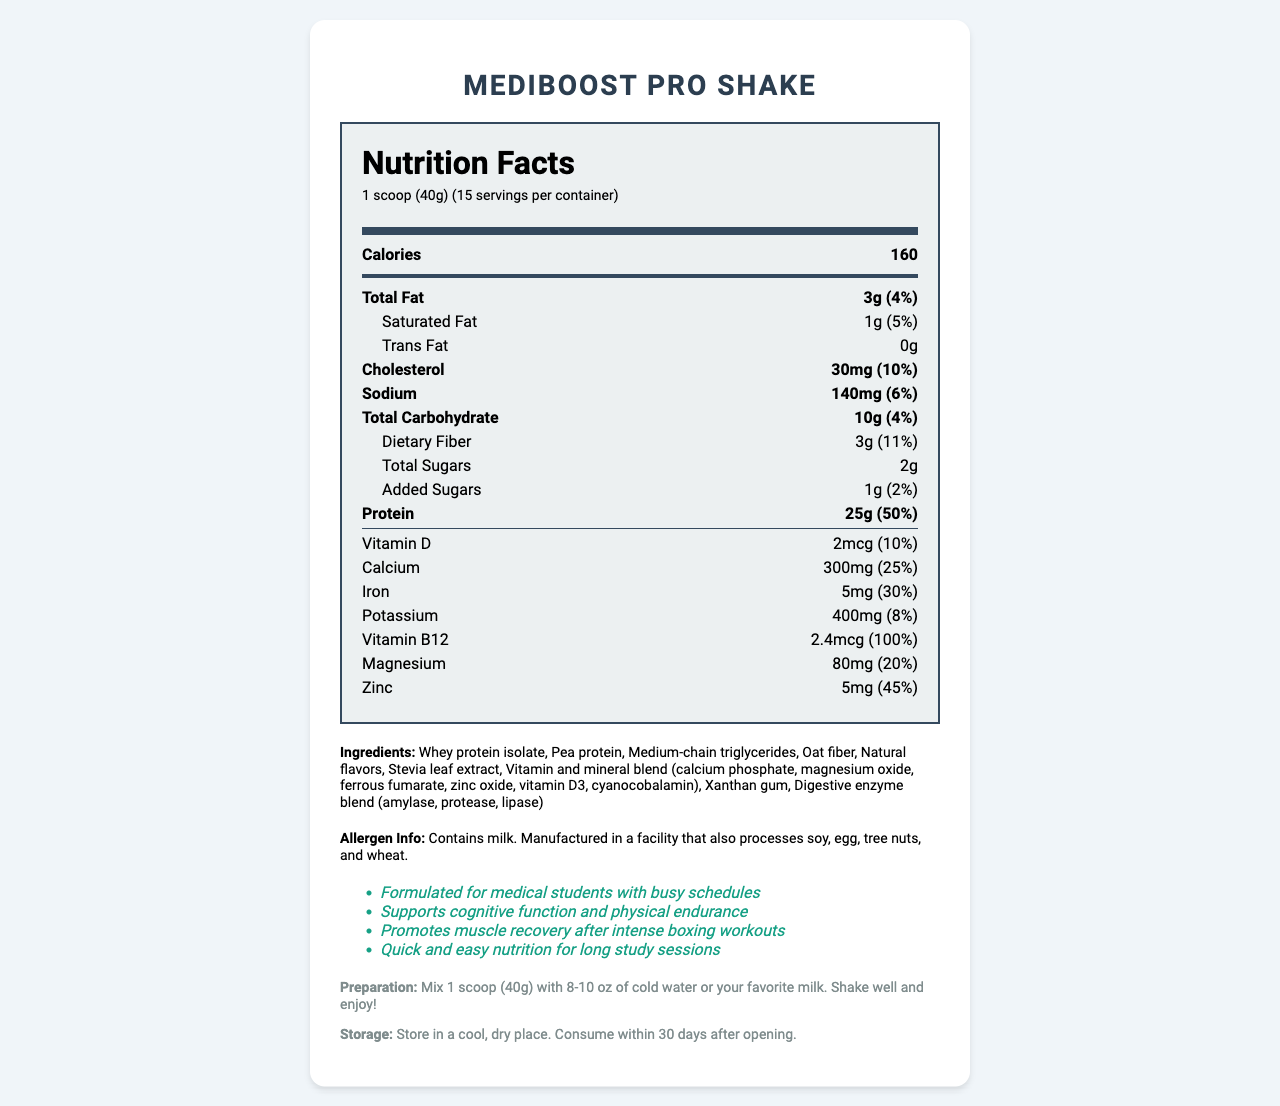what is the serving size for MediBoost Pro Shake? The serving size is listed at the top of the nutrition facts label as "1 scoop (40g)".
Answer: 1 scoop (40g) how many calories are in one serving? The document states that there are 160 calories per serving.
Answer: 160 what percentage of the daily value of protein does one serving provide? The protein section indicates 25g per serving, which is 50% of the daily value.
Answer: 50% list three main ingredients in MediBoost Pro Shake. These three ingredients are listed first in the ingredients list, suggesting they are the main ones.
Answer: Whey protein isolate, Pea protein, Medium-chain triglycerides is there any trans fat in this product? The document states that the amount of trans fat is 0g.
Answer: No how much dietary fiber is in one serving, and what is its daily value percentage? The dietary fiber section indicates it has 3g per serving, which is 11% of the daily value.
Answer: 3g, 11% which vitamin has the highest daily value percentage in one serving? The vitamin B12 section shows a daily value percentage of 100%, which is the highest among the listed vitamins.
Answer: Vitamin B12 (100%) how much sodium is in one serving? The sodium section indicates that there are 140mg of sodium per serving.
Answer: 140mg what is the amount of cholesterol in one serving, and what is its daily value percentage? The cholesterol section indicates it has 30mg per serving, which is 10% of the daily value.
Answer: 30mg, 10% which of the following claims is not made about MediBoost Pro Shake? A. Helps with weight loss B. Supports cognitive function C. Promotes muscle recovery D. Quick and easy nutrition for long study sessions The document lists claims but does not mention helping with weight loss.
Answer: A. Helps with weight loss what is the total number of servings in one container? The document notes that there are 15 servings per container.
Answer: 15 true or false: This product contains gluten. The allergen info states that it contains milk and is manufactured in a facility that processes other allergens, but there is no mention of gluten specifically.
Answer: False summarize the main purpose and benefits of MediBoost Pro Shake. The document highlights the product's purpose and its various benefits tailored for medical students, including cognitive support, muscle recovery, and ease of use.
Answer: MediBoost Pro Shake is a lean, protein-rich meal replacement shake designed for medical students with busy schedules. It supports cognitive function and physical endurance, promotes muscle recovery after intense workouts, and offers quick and easy nutrition for long study sessions. what does the product recommend as the quantity of liquid to mix with one serving of MediBoost Pro Shake? A. 6-8 oz B. 8-10 oz C. 10-12 oz D. 12-14 oz The preparation instructions indicate mixing one scoop with 8-10 oz of cold water or milk.
Answer: B. 8-10 oz why might MediBoost Pro Shake be particularly suitable for someone who practices boxing? The claim statements include a specific benefit of promoting muscle recovery, which is beneficial for someone engaged in regular, intense physical activities like boxing.
Answer: It promotes muscle recovery after intense workouts. what is the total amount of sugars in one serving? The total sugars section indicates there are 2g of sugars per serving.
Answer: 2g how much iron does one serving of MediBoost Pro Shake provide in terms of daily value percentage? The iron section indicates a daily value percentage of 30%.
Answer: 30% what information is missing about the manufacturing date of MediBoost Pro Shake? The document does not include any information about the manufacturing date, making it impossible to determine from the given information.
Answer: The manufacturing date is not provided. how long can you store the product after opening it? The storage instructions specify consuming the product within 30 days after opening.
Answer: 30 days 